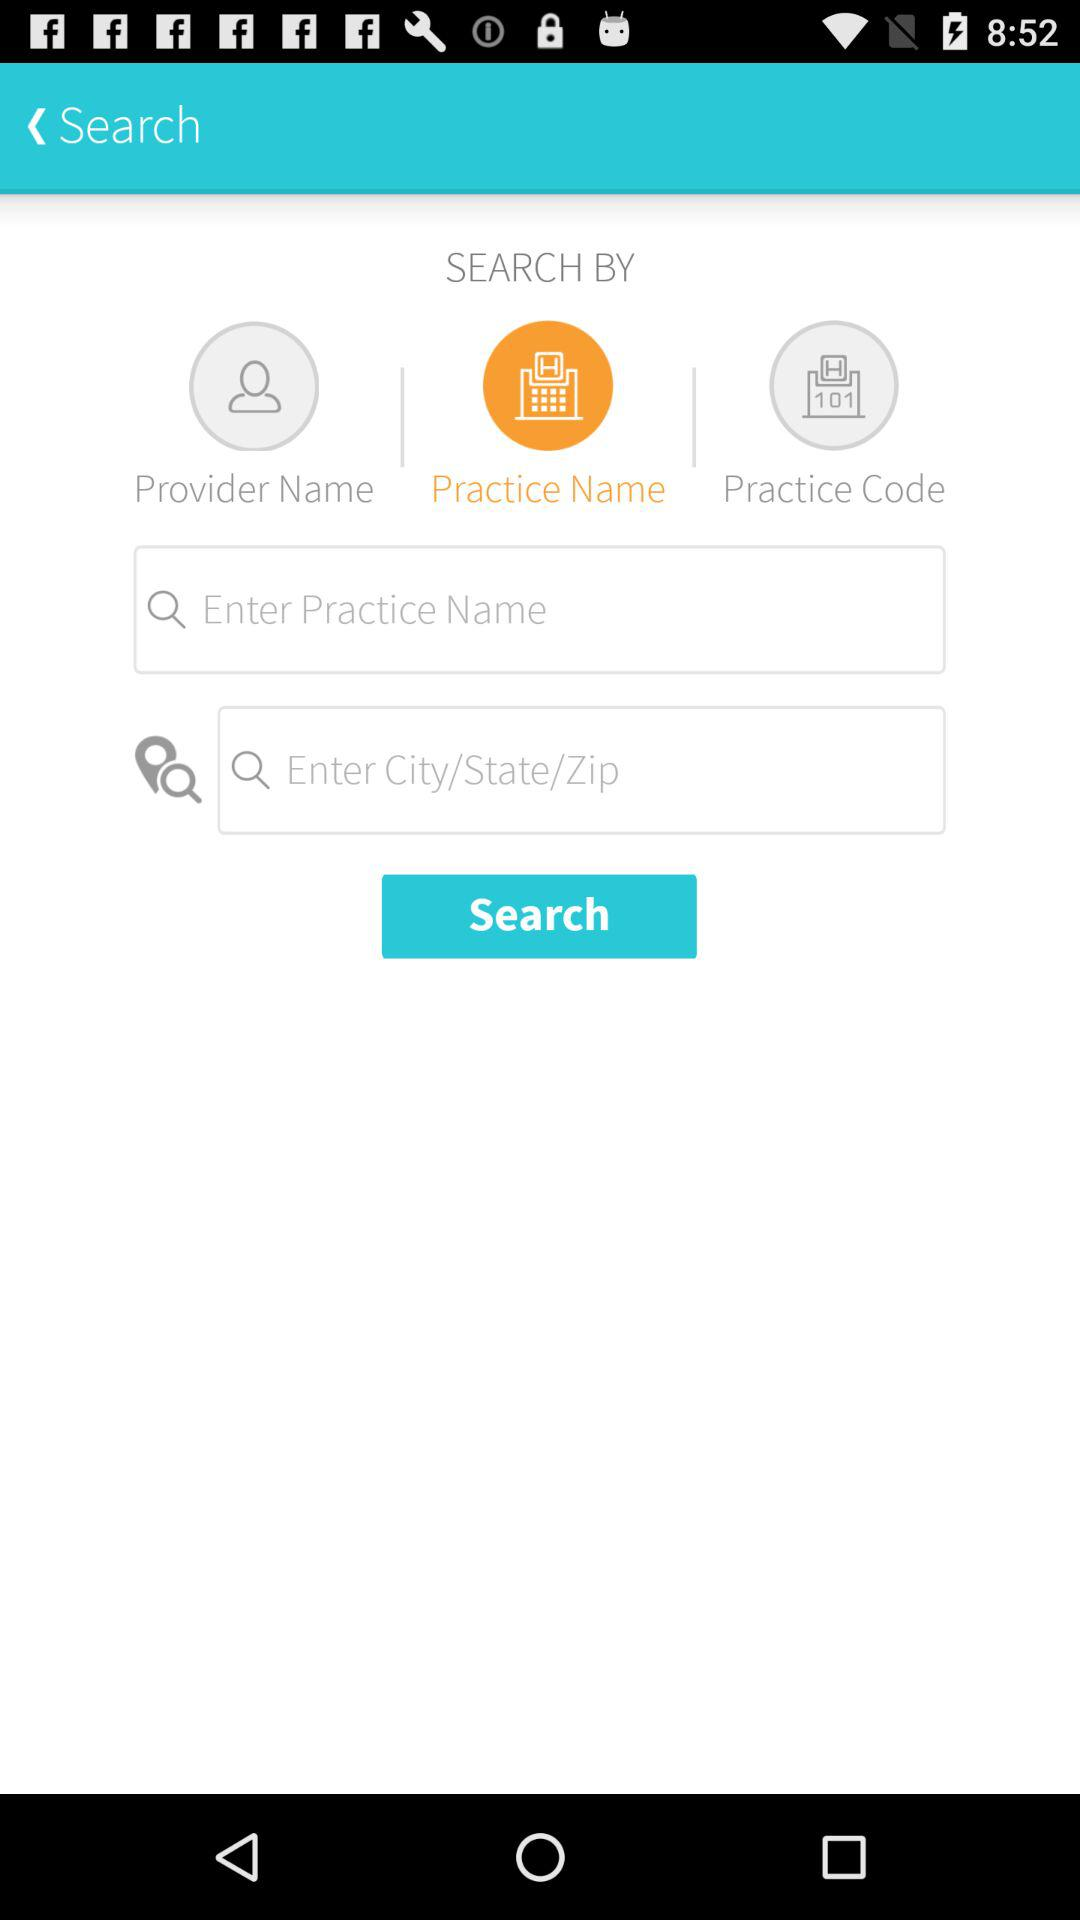Which tab am I on? You are on "Practice Name" tab. 